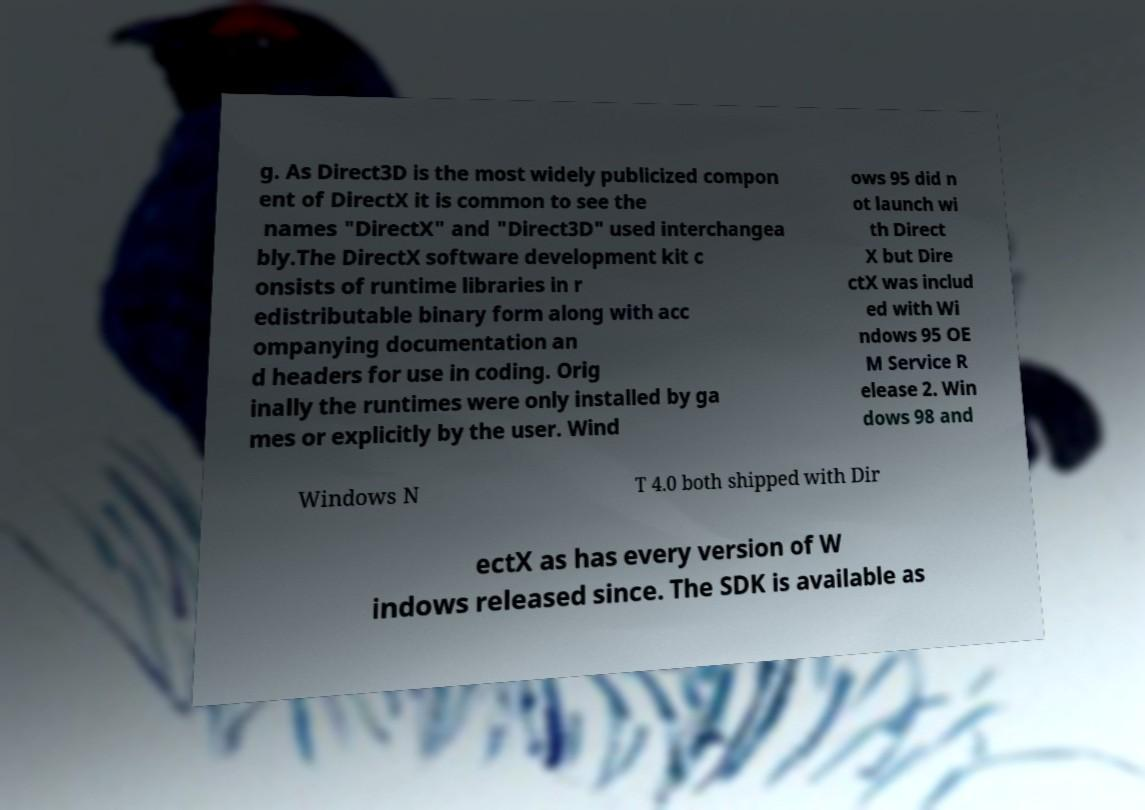Please read and relay the text visible in this image. What does it say? g. As Direct3D is the most widely publicized compon ent of DirectX it is common to see the names "DirectX" and "Direct3D" used interchangea bly.The DirectX software development kit c onsists of runtime libraries in r edistributable binary form along with acc ompanying documentation an d headers for use in coding. Orig inally the runtimes were only installed by ga mes or explicitly by the user. Wind ows 95 did n ot launch wi th Direct X but Dire ctX was includ ed with Wi ndows 95 OE M Service R elease 2. Win dows 98 and Windows N T 4.0 both shipped with Dir ectX as has every version of W indows released since. The SDK is available as 